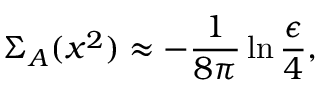Convert formula to latex. <formula><loc_0><loc_0><loc_500><loc_500>\Sigma _ { A } ( x ^ { 2 } ) \approx - \frac { 1 } { 8 \pi } \ln \frac { \epsilon } { 4 } ,</formula> 